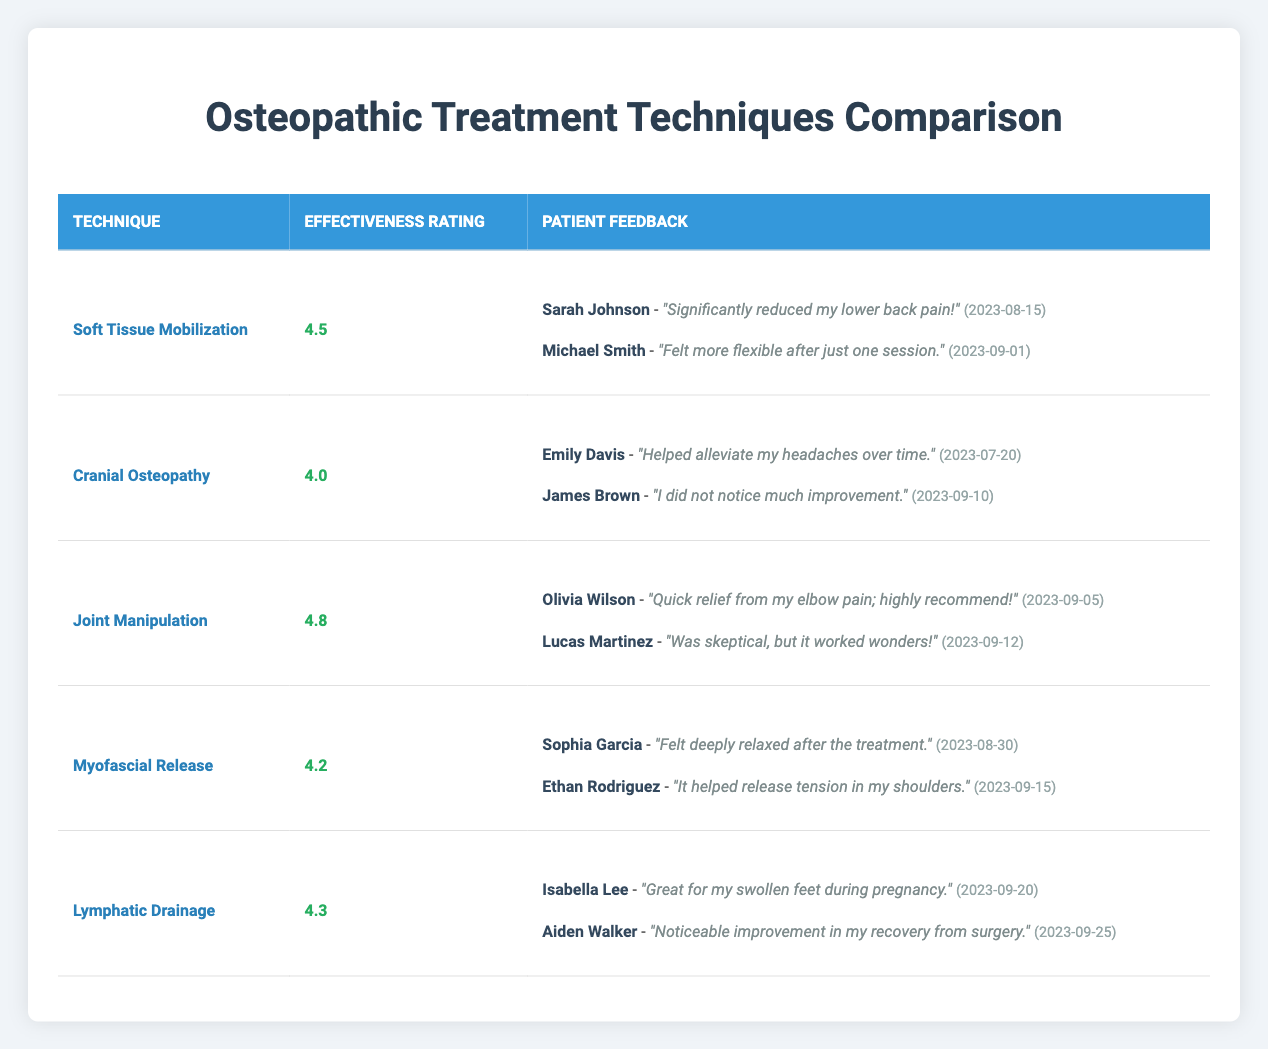What is the effectiveness rating for Joint Manipulation? The table shows that Joint Manipulation has an effectiveness rating listed next to it, which is 4.8.
Answer: 4.8 Which technique received the lowest effectiveness rating? By examining the table, Cranial Osteopathy has the lowest effectiveness rating of 4.0 compared to all other techniques listed.
Answer: Cranial Osteopathy How many patient feedback reviews are there for Myofascial Release? The table indicates there are two reviews listed under the Myofascial Release technique.
Answer: 2 What was the feedback from Emily Davis regarding Cranial Osteopathy? The table contains Emily Davis's feedback stating that Cranial Osteopathy "helped alleviate my headaches over time."
Answer: "Helped alleviate my headaches over time." Is the effectiveness rating for Lymphatic Drainage higher than that of Myofascial Release? Comparing the effectiveness ratings, Lymphatic Drainage has a rating of 4.3, while Myofascial Release has a rating of 4.2, making Lymphatic Drainage higher.
Answer: Yes What is the average effectiveness rating of all treatment techniques shown in the table? To find the average, sum the effectiveness ratings (4.5 + 4.0 + 4.8 + 4.2 + 4.3 = 21.8) and divide by the total number of techniques (5), resulting in an average of 21.8 / 5 = 4.36.
Answer: 4.36 Did any patient express skepticism but end up satisfied after treatment? Yes, Lucas Martinez indicated he was skeptical about Joint Manipulation, but his feedback shows that it "worked wonders," reflecting satisfaction after treatment.
Answer: Yes Which technique has a patient feedback that mentions improvement in recovery from surgery? The feedback from Aiden Walker under Lymphatic Drainage states that it led to "noticeable improvement in my recovery from surgery."
Answer: Lymphatic Drainage What is the combined effectiveness rating of Soft Tissue Mobilization and Myofascial Release? The combined effectiveness rating is found by adding their ratings (4.5 for Soft Tissue Mobilization and 4.2 for Myofascial Release), resulting in 4.5 + 4.2 = 8.7.
Answer: 8.7 What percentage of the techniques have an effectiveness rating above 4.5? Three out of the five techniques have a rating above 4.5 (Soft Tissue Mobilization, Joint Manipulation, and Myofascial Release), which gives us a percentage of (3/5) * 100 = 60%.
Answer: 60% 